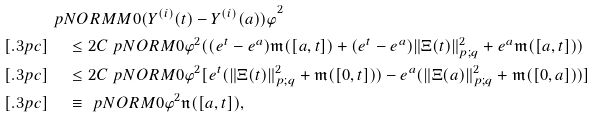<formula> <loc_0><loc_0><loc_500><loc_500>& \ p N O R M M { 0 } { ( Y ^ { ( i ) } ( t ) - Y ^ { ( i ) } ( a ) ) \varphi } ^ { 2 } \\ [ . 3 p c ] & \quad \, \leq 2 C \ p N O R M { 0 } { \varphi } ^ { 2 } ( ( e ^ { t } - e ^ { a } ) \mathfrak { m } ( [ a , t ] ) + ( e ^ { t } - e ^ { a } ) \| \Xi ( t ) \| _ { p ; q } ^ { 2 } + e ^ { a } \mathfrak { m } ( [ a , t ] ) ) \\ [ . 3 p c ] & \quad \, \leq 2 C \ p N O R M { 0 } { \varphi } ^ { 2 } [ e ^ { t } ( \| \Xi ( t ) \| _ { p ; q } ^ { 2 } + \mathfrak { m } ( [ 0 , t ] ) ) - e ^ { a } ( \| \Xi ( a ) \| _ { p ; q } ^ { 2 } + \mathfrak { m } ( [ 0 , a ] ) ) ] \\ [ . 3 p c ] & \quad \, \equiv \ p N O R M { 0 } { \varphi } ^ { 2 } \mathfrak { n } ( [ a , t ] ) ,</formula> 